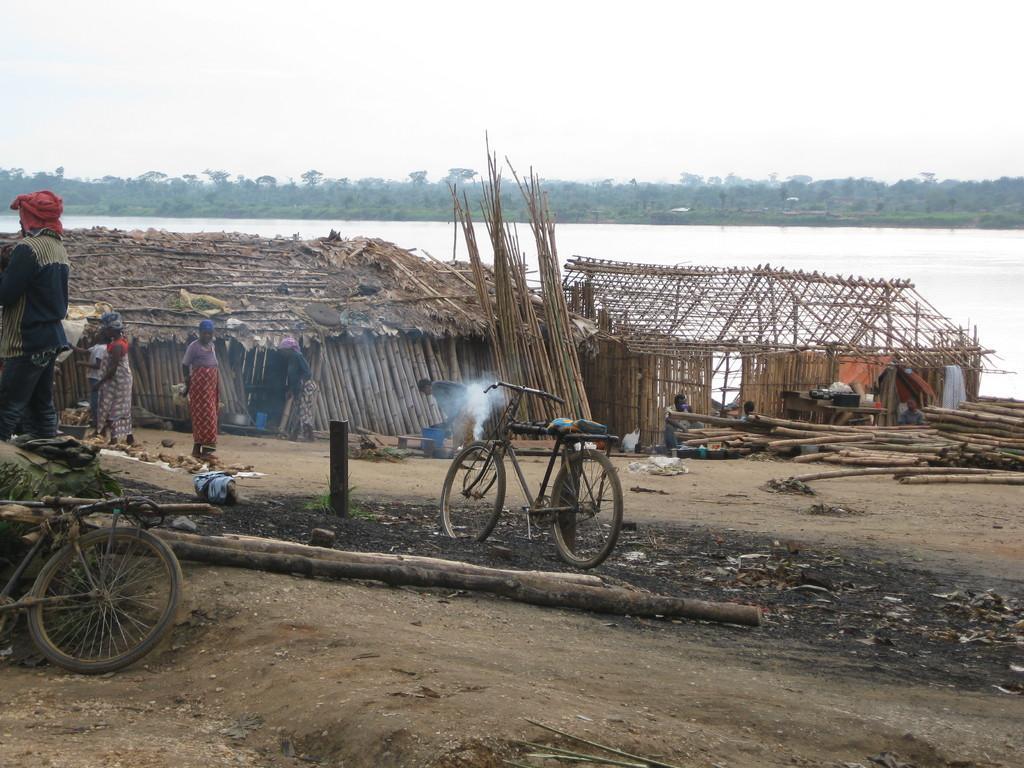How would you summarize this image in a sentence or two? In this image I can see two bicycles, number of wooden poles, two houses and few people. In the center of the image I can see the smoke. In the background I can see water, number of trees and the sky. 